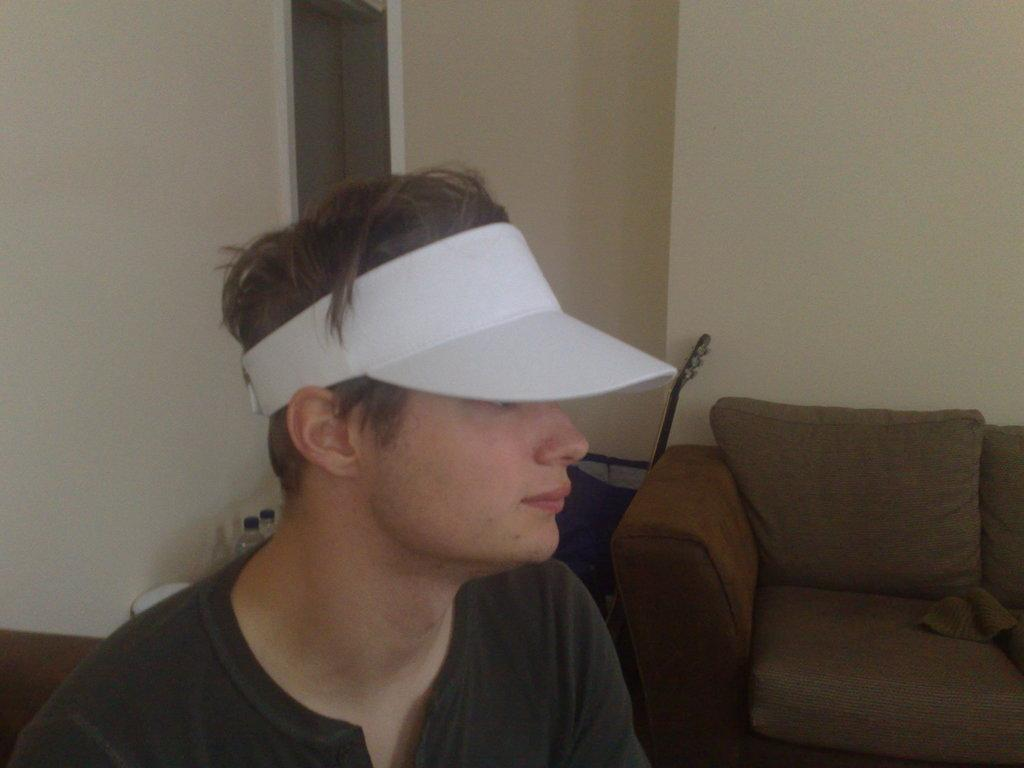Who is the main subject in the image? There is a boy in the image. What is the boy doing in the image? The boy is seated on a chair. What object is near the boy? There is a guitar on the side. How many chairs are visible in the image? There are two chairs visible in the image. What is the boy wearing on his head? The boy is wearing a white cap. What items can be seen for hydration in the image? There are water bottles visible in the image. What type of pipe is the boy playing in the image? There is no pipe present in the image; the boy is near a guitar, not a pipe. 